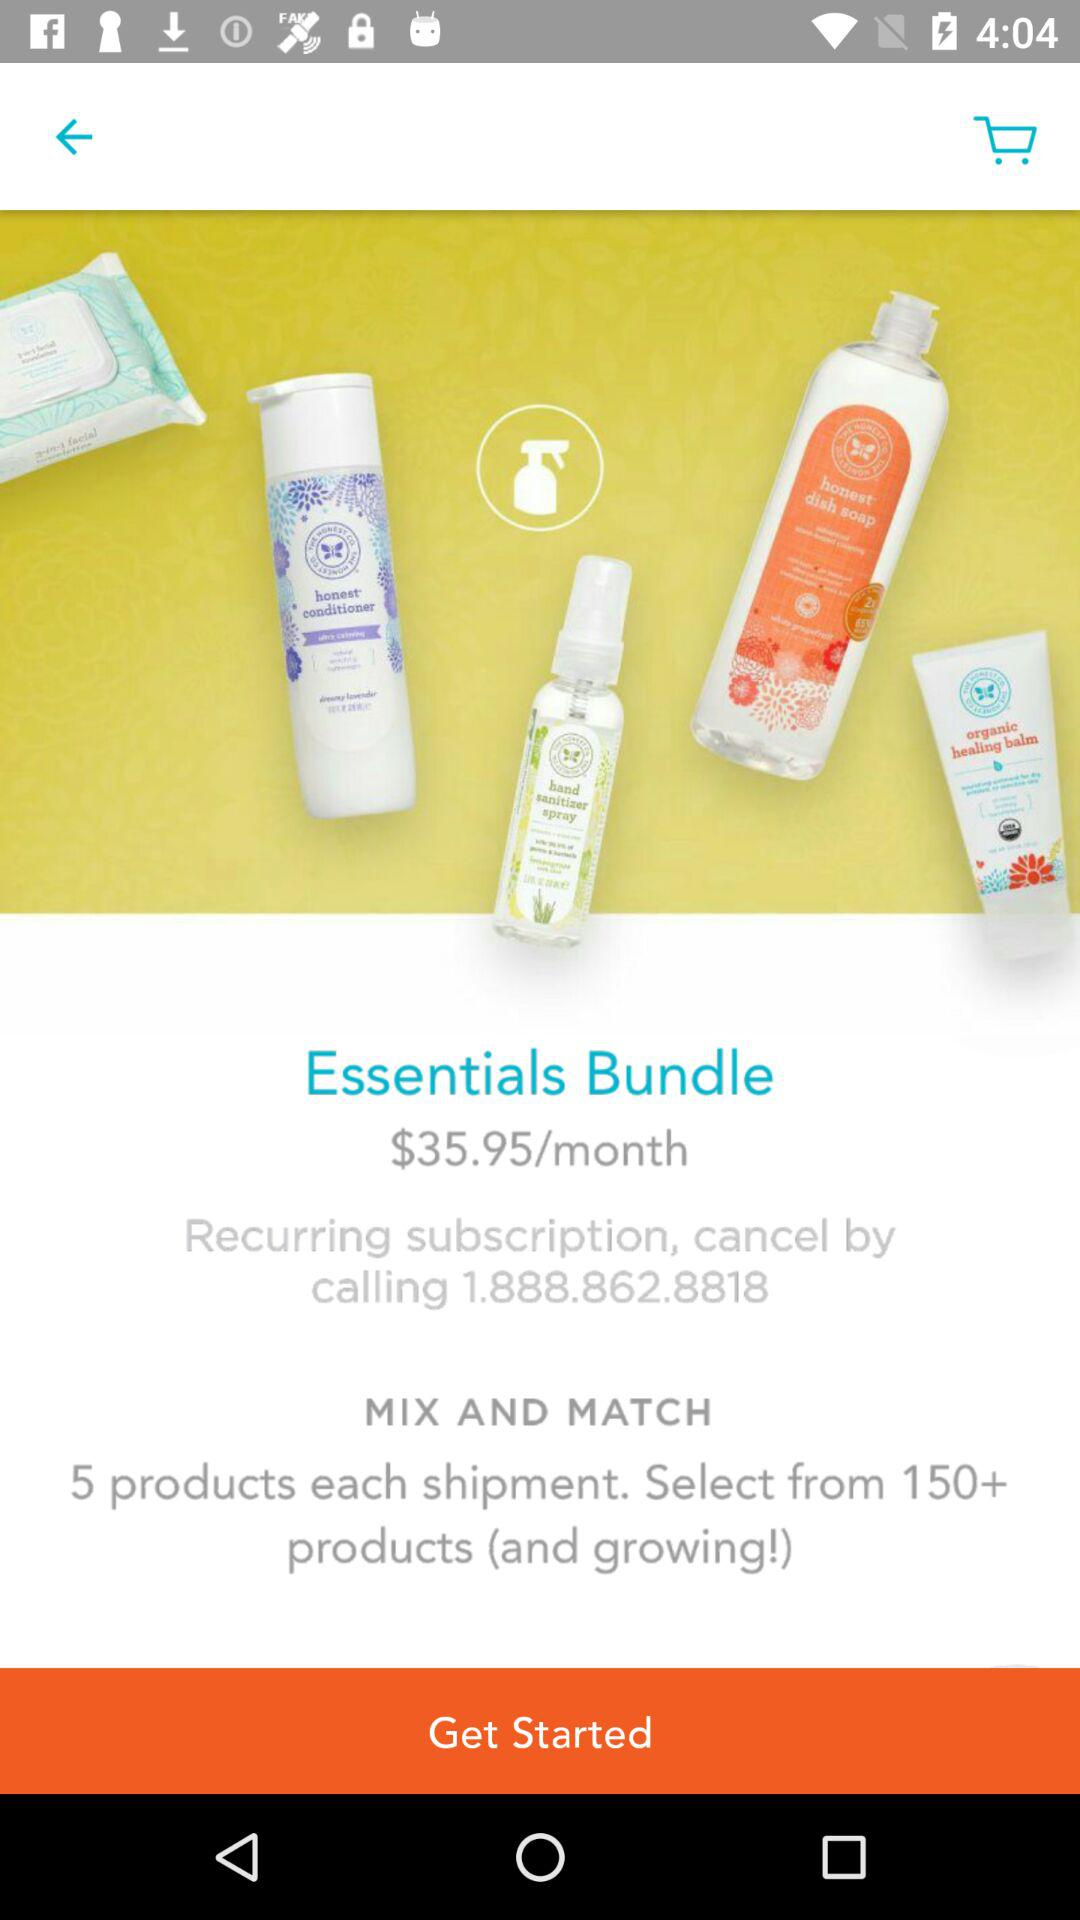What is the contact number for cancelling orders? The contact number for cancelling orders is 1.888.862.8818. 